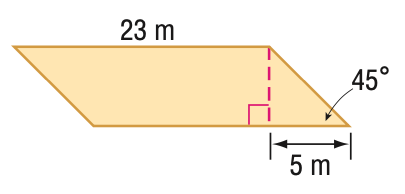Question: Find the perimeter of the parallelogram. Round to the nearest tenth if necessary.
Choices:
A. 53.1
B. 56
C. 60.1
D. 63.3
Answer with the letter. Answer: C Question: Find the area of the parallelogram. Round to the nearest tenth if necessary.
Choices:
A. 57.5
B. 81.3
C. 99.6
D. 115
Answer with the letter. Answer: D 